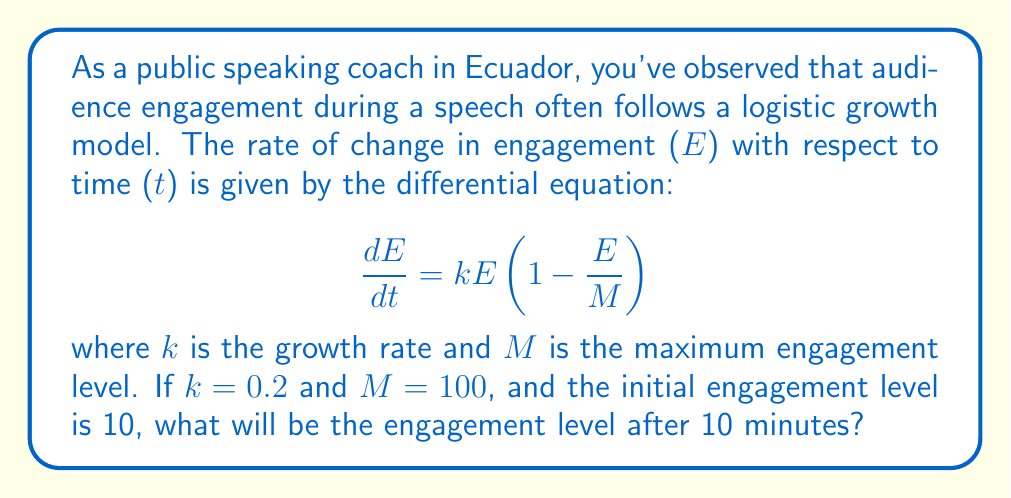Show me your answer to this math problem. To solve this problem, we need to follow these steps:

1. Identify the given differential equation:
   $$\frac{dE}{dt} = kE(1-\frac{E}{M})$$

2. Substitute the given values:
   k = 0.2
   M = 100
   Initial engagement E(0) = 10
   Time t = 10 minutes

3. The solution to this logistic differential equation is:
   $$E(t) = \frac{M}{1 + (\frac{M}{E_0} - 1)e^{-kt}}$$

   Where E_0 is the initial engagement level.

4. Substitute the values into the solution:
   $$E(t) = \frac{100}{1 + (\frac{100}{10} - 1)e^{-0.2t}}$$

5. Simplify:
   $$E(t) = \frac{100}{1 + 9e^{-0.2t}}$$

6. Calculate E(10) by substituting t = 10:
   $$E(10) = \frac{100}{1 + 9e^{-0.2(10)}}$$

7. Evaluate:
   $$E(10) = \frac{100}{1 + 9e^{-2}} \approx 59.97$$

Therefore, the engagement level after 10 minutes will be approximately 59.97.
Answer: 59.97 